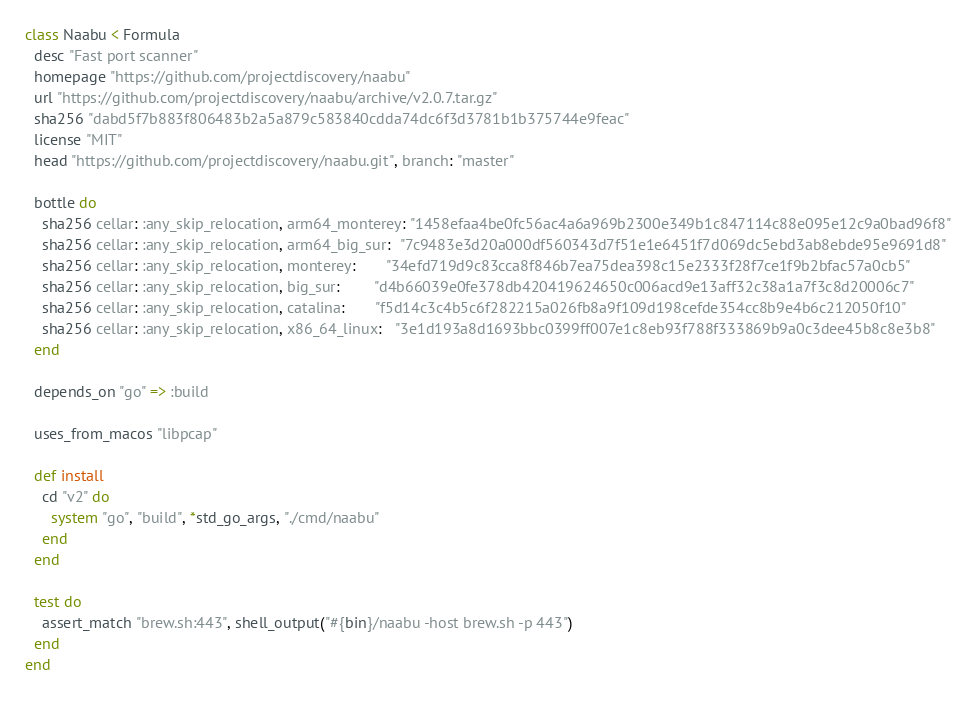Convert code to text. <code><loc_0><loc_0><loc_500><loc_500><_Ruby_>class Naabu < Formula
  desc "Fast port scanner"
  homepage "https://github.com/projectdiscovery/naabu"
  url "https://github.com/projectdiscovery/naabu/archive/v2.0.7.tar.gz"
  sha256 "dabd5f7b883f806483b2a5a879c583840cdda74dc6f3d3781b1b375744e9feac"
  license "MIT"
  head "https://github.com/projectdiscovery/naabu.git", branch: "master"

  bottle do
    sha256 cellar: :any_skip_relocation, arm64_monterey: "1458efaa4be0fc56ac4a6a969b2300e349b1c847114c88e095e12c9a0bad96f8"
    sha256 cellar: :any_skip_relocation, arm64_big_sur:  "7c9483e3d20a000df560343d7f51e1e6451f7d069dc5ebd3ab8ebde95e9691d8"
    sha256 cellar: :any_skip_relocation, monterey:       "34efd719d9c83cca8f846b7ea75dea398c15e2333f28f7ce1f9b2bfac57a0cb5"
    sha256 cellar: :any_skip_relocation, big_sur:        "d4b66039e0fe378db420419624650c006acd9e13aff32c38a1a7f3c8d20006c7"
    sha256 cellar: :any_skip_relocation, catalina:       "f5d14c3c4b5c6f282215a026fb8a9f109d198cefde354cc8b9e4b6c212050f10"
    sha256 cellar: :any_skip_relocation, x86_64_linux:   "3e1d193a8d1693bbc0399ff007e1c8eb93f788f333869b9a0c3dee45b8c8e3b8"
  end

  depends_on "go" => :build

  uses_from_macos "libpcap"

  def install
    cd "v2" do
      system "go", "build", *std_go_args, "./cmd/naabu"
    end
  end

  test do
    assert_match "brew.sh:443", shell_output("#{bin}/naabu -host brew.sh -p 443")
  end
end
</code> 